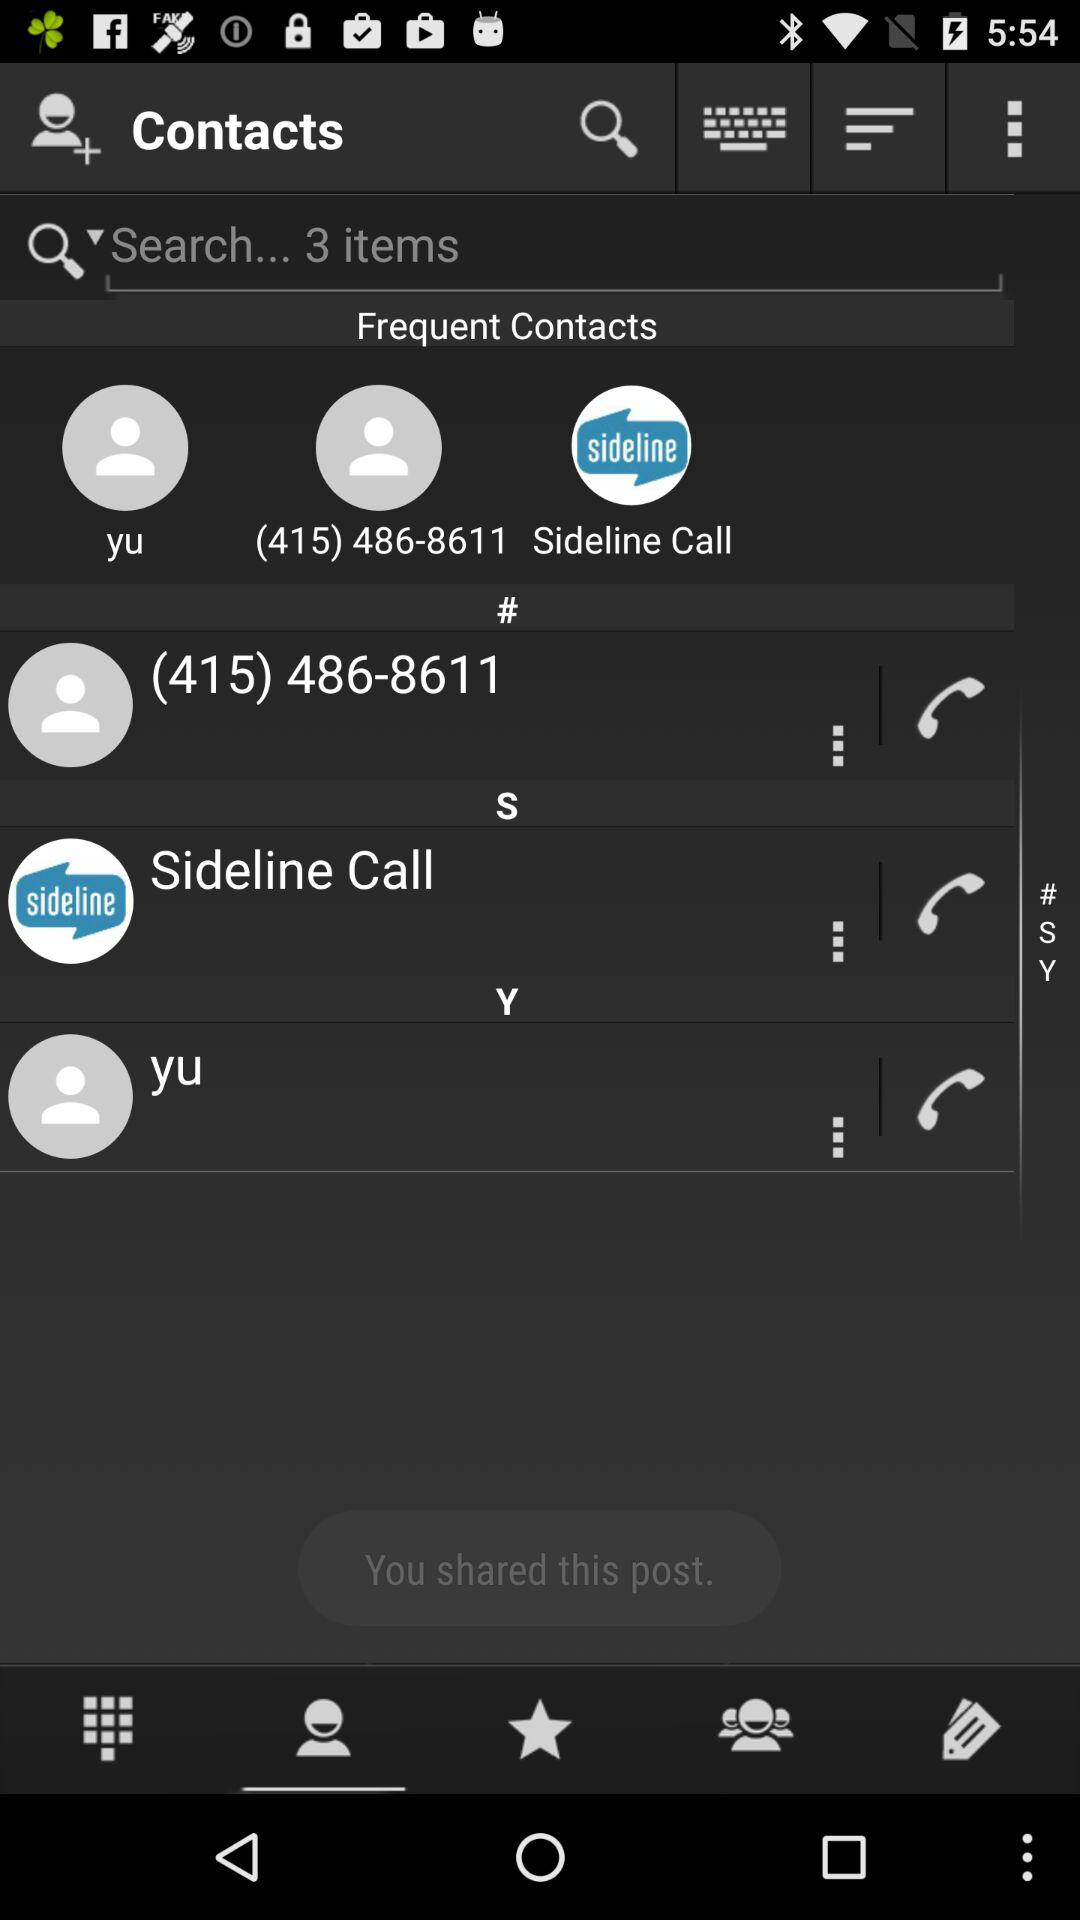How many items can be searched? There are 3 items that can be searched. 